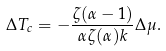<formula> <loc_0><loc_0><loc_500><loc_500>\Delta T _ { c } = - \frac { \zeta ( \alpha - 1 ) } { \alpha \zeta ( \alpha ) k } \Delta \mu .</formula> 